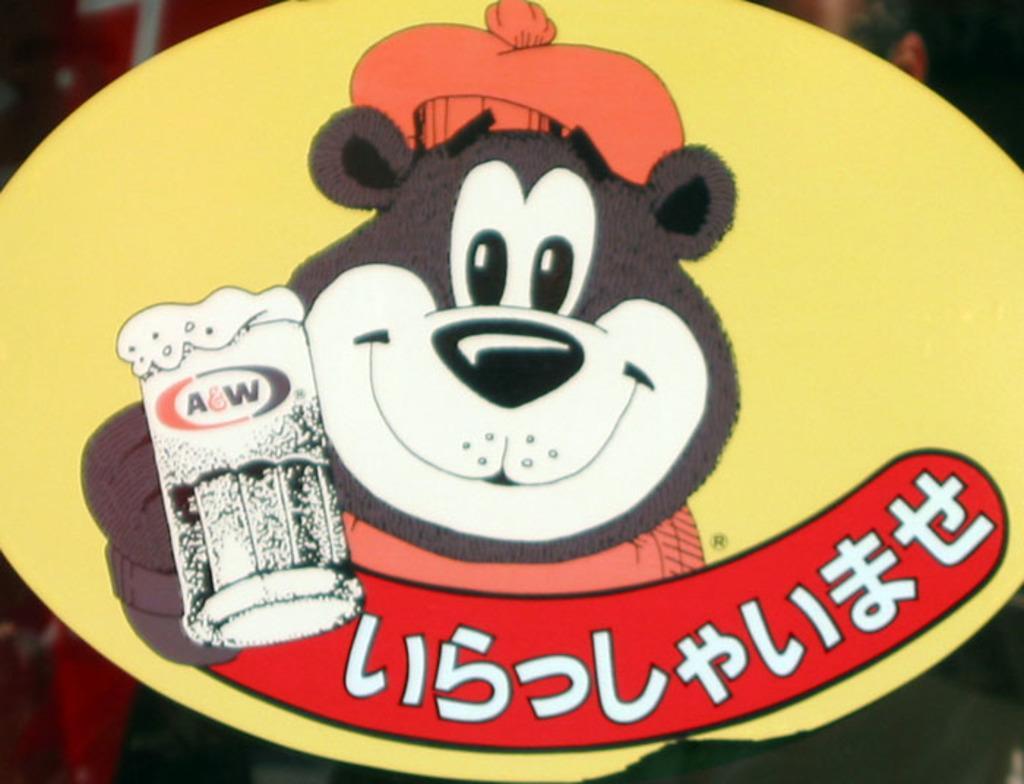Please provide a concise description of this image. In this picture, there is a board. On the board, there is a bear cartoon holding a glass. Below it, there is a text. 